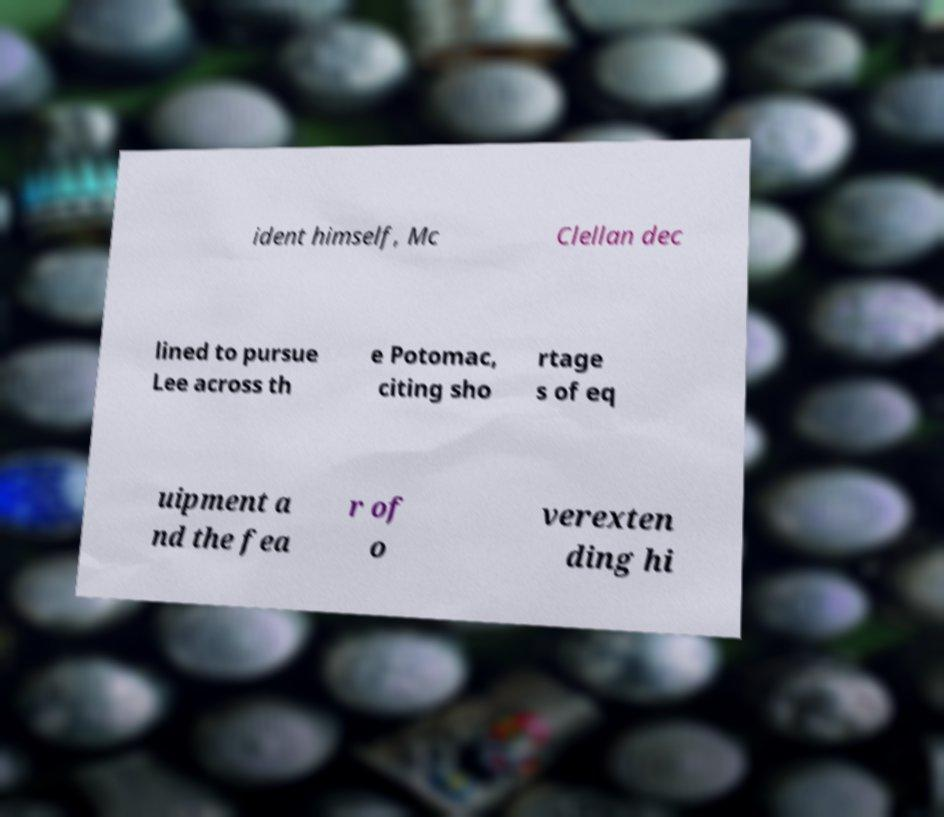Can you accurately transcribe the text from the provided image for me? ident himself, Mc Clellan dec lined to pursue Lee across th e Potomac, citing sho rtage s of eq uipment a nd the fea r of o verexten ding hi 